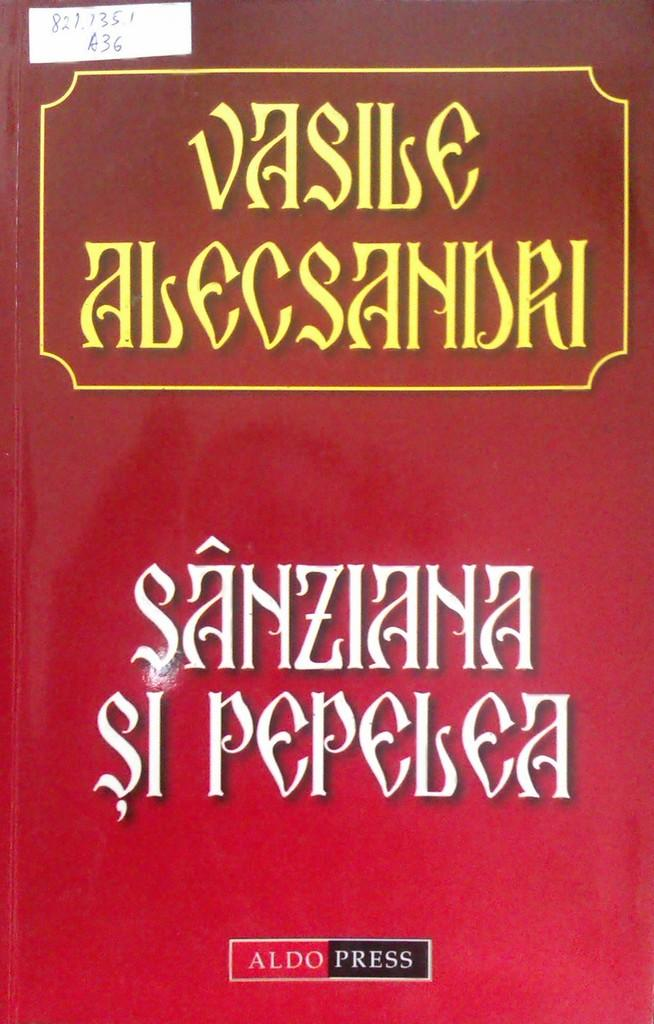Provide a one-sentence caption for the provided image. A red book titled Vasile Alecsandri in yellow text. 